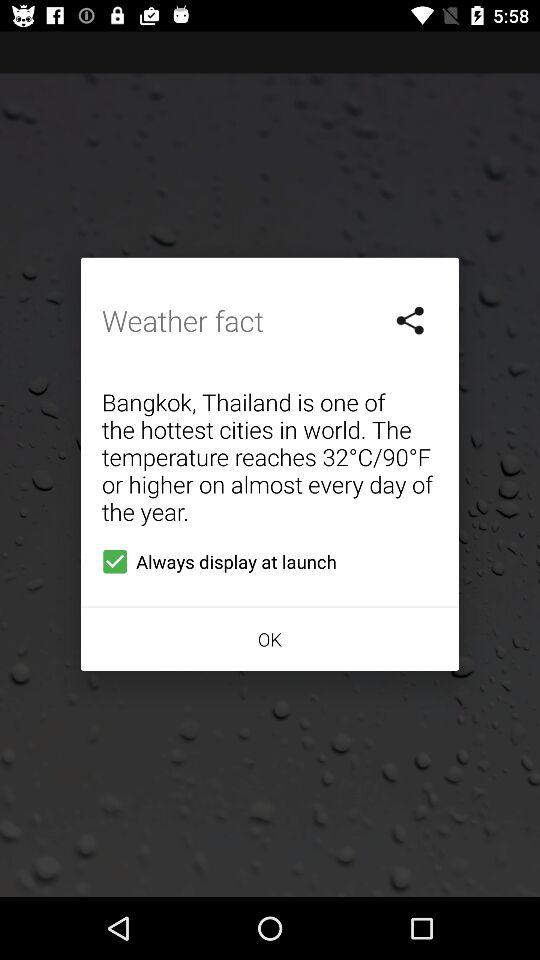How high can the temperature get in Bangkok, Thailand? The temperature can get to 32 °C (90 °F) or higher. 